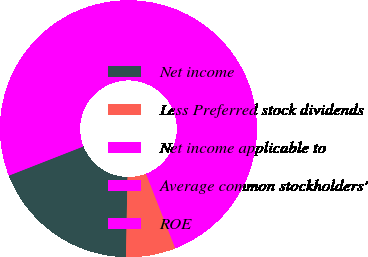Convert chart. <chart><loc_0><loc_0><loc_500><loc_500><pie_chart><fcel>Net income<fcel>Less Preferred stock dividends<fcel>Net income applicable to<fcel>Average common stockholders'<fcel>ROE<nl><fcel>18.75%<fcel>6.25%<fcel>12.5%<fcel>62.49%<fcel>0.0%<nl></chart> 